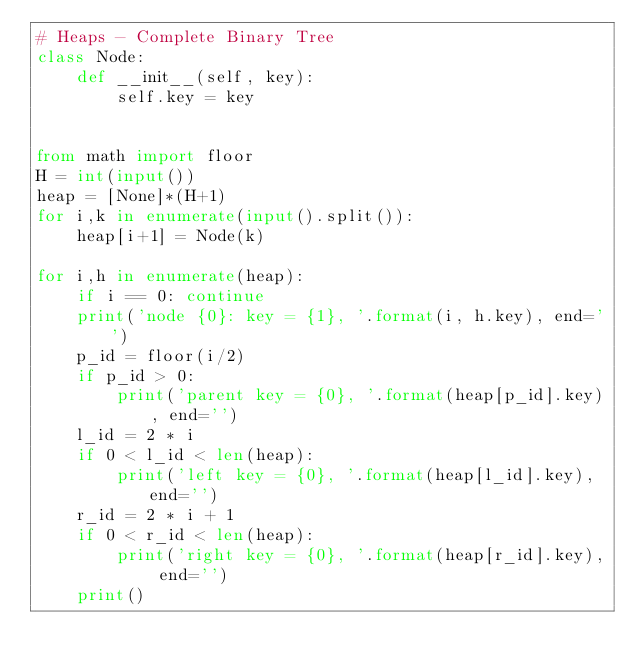Convert code to text. <code><loc_0><loc_0><loc_500><loc_500><_Python_># Heaps - Complete Binary Tree
class Node:
    def __init__(self, key):
        self.key = key


from math import floor
H = int(input())
heap = [None]*(H+1)
for i,k in enumerate(input().split()):
    heap[i+1] = Node(k)

for i,h in enumerate(heap):
    if i == 0: continue
    print('node {0}: key = {1}, '.format(i, h.key), end='')
    p_id = floor(i/2)
    if p_id > 0:
        print('parent key = {0}, '.format(heap[p_id].key), end='')
    l_id = 2 * i
    if 0 < l_id < len(heap):
        print('left key = {0}, '.format(heap[l_id].key), end='')
    r_id = 2 * i + 1
    if 0 < r_id < len(heap):
        print('right key = {0}, '.format(heap[r_id].key), end='')
    print()
</code> 